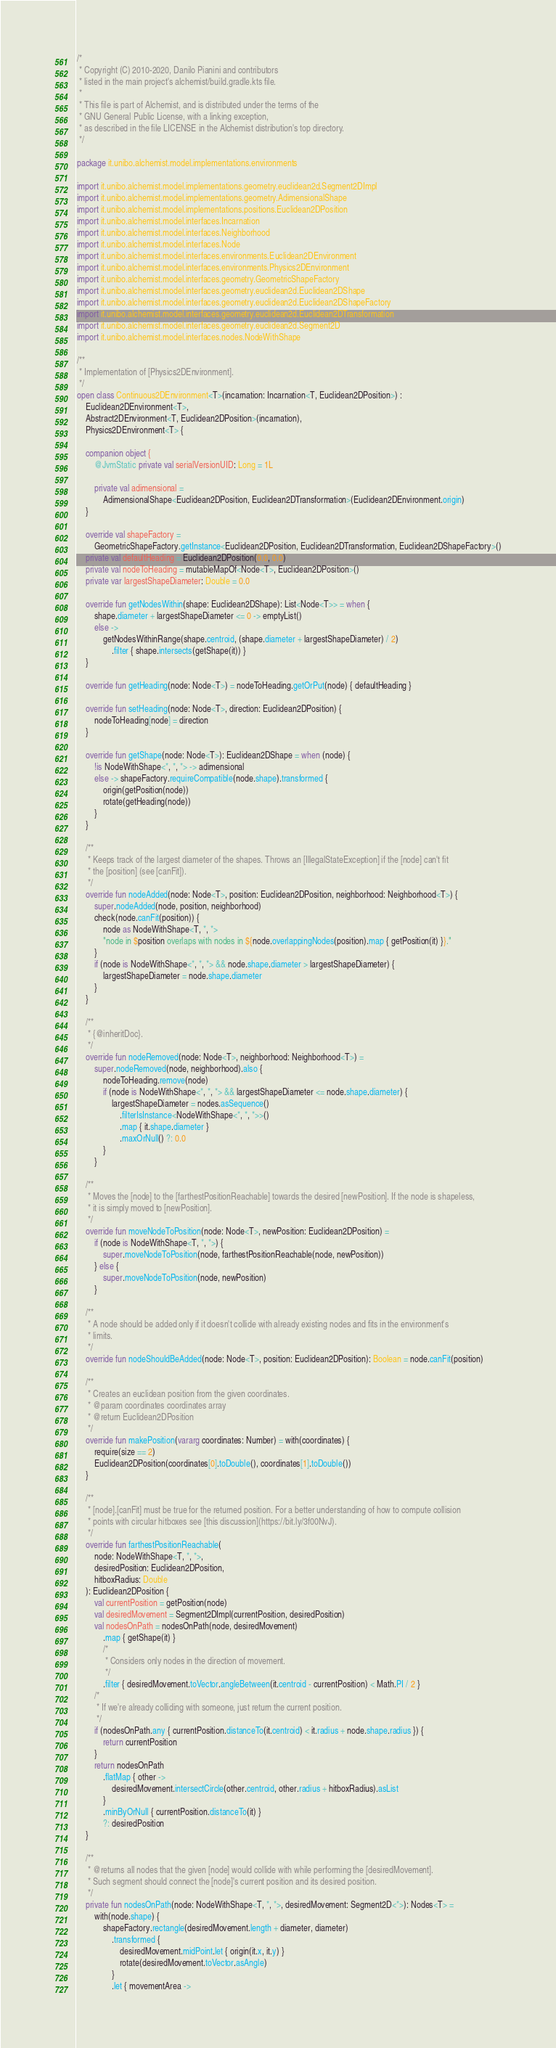Convert code to text. <code><loc_0><loc_0><loc_500><loc_500><_Kotlin_>/*
 * Copyright (C) 2010-2020, Danilo Pianini and contributors
 * listed in the main project's alchemist/build.gradle.kts file.
 *
 * This file is part of Alchemist, and is distributed under the terms of the
 * GNU General Public License, with a linking exception,
 * as described in the file LICENSE in the Alchemist distribution's top directory.
 */

package it.unibo.alchemist.model.implementations.environments

import it.unibo.alchemist.model.implementations.geometry.euclidean2d.Segment2DImpl
import it.unibo.alchemist.model.implementations.geometry.AdimensionalShape
import it.unibo.alchemist.model.implementations.positions.Euclidean2DPosition
import it.unibo.alchemist.model.interfaces.Incarnation
import it.unibo.alchemist.model.interfaces.Neighborhood
import it.unibo.alchemist.model.interfaces.Node
import it.unibo.alchemist.model.interfaces.environments.Euclidean2DEnvironment
import it.unibo.alchemist.model.interfaces.environments.Physics2DEnvironment
import it.unibo.alchemist.model.interfaces.geometry.GeometricShapeFactory
import it.unibo.alchemist.model.interfaces.geometry.euclidean2d.Euclidean2DShape
import it.unibo.alchemist.model.interfaces.geometry.euclidean2d.Euclidean2DShapeFactory
import it.unibo.alchemist.model.interfaces.geometry.euclidean2d.Euclidean2DTransformation
import it.unibo.alchemist.model.interfaces.geometry.euclidean2d.Segment2D
import it.unibo.alchemist.model.interfaces.nodes.NodeWithShape

/**
 * Implementation of [Physics2DEnvironment].
 */
open class Continuous2DEnvironment<T>(incarnation: Incarnation<T, Euclidean2DPosition>) :
    Euclidean2DEnvironment<T>,
    Abstract2DEnvironment<T, Euclidean2DPosition>(incarnation),
    Physics2DEnvironment<T> {

    companion object {
        @JvmStatic private val serialVersionUID: Long = 1L

        private val adimensional =
            AdimensionalShape<Euclidean2DPosition, Euclidean2DTransformation>(Euclidean2DEnvironment.origin)
    }

    override val shapeFactory =
        GeometricShapeFactory.getInstance<Euclidean2DPosition, Euclidean2DTransformation, Euclidean2DShapeFactory>()
    private val defaultHeading = Euclidean2DPosition(0.0, 0.0)
    private val nodeToHeading = mutableMapOf<Node<T>, Euclidean2DPosition>()
    private var largestShapeDiameter: Double = 0.0

    override fun getNodesWithin(shape: Euclidean2DShape): List<Node<T>> = when {
        shape.diameter + largestShapeDiameter <= 0 -> emptyList()
        else ->
            getNodesWithinRange(shape.centroid, (shape.diameter + largestShapeDiameter) / 2)
                .filter { shape.intersects(getShape(it)) }
    }

    override fun getHeading(node: Node<T>) = nodeToHeading.getOrPut(node) { defaultHeading }

    override fun setHeading(node: Node<T>, direction: Euclidean2DPosition) {
        nodeToHeading[node] = direction
    }

    override fun getShape(node: Node<T>): Euclidean2DShape = when (node) {
        !is NodeWithShape<*, *, *> -> adimensional
        else -> shapeFactory.requireCompatible(node.shape).transformed {
            origin(getPosition(node))
            rotate(getHeading(node))
        }
    }

    /**
     * Keeps track of the largest diameter of the shapes. Throws an [IllegalStateException] if the [node] can't fit
     * the [position] (see [canFit]).
     */
    override fun nodeAdded(node: Node<T>, position: Euclidean2DPosition, neighborhood: Neighborhood<T>) {
        super.nodeAdded(node, position, neighborhood)
        check(node.canFit(position)) {
            node as NodeWithShape<T, *, *>
            "node in $position overlaps with nodes in ${node.overlappingNodes(position).map { getPosition(it) }}."
        }
        if (node is NodeWithShape<*, *, *> && node.shape.diameter > largestShapeDiameter) {
            largestShapeDiameter = node.shape.diameter
        }
    }

    /**
     * {@inheritDoc}.
     */
    override fun nodeRemoved(node: Node<T>, neighborhood: Neighborhood<T>) =
        super.nodeRemoved(node, neighborhood).also {
            nodeToHeading.remove(node)
            if (node is NodeWithShape<*, *, *> && largestShapeDiameter <= node.shape.diameter) {
                largestShapeDiameter = nodes.asSequence()
                    .filterIsInstance<NodeWithShape<*, *, *>>()
                    .map { it.shape.diameter }
                    .maxOrNull() ?: 0.0
            }
        }

    /**
     * Moves the [node] to the [farthestPositionReachable] towards the desired [newPosition]. If the node is shapeless,
     * it is simply moved to [newPosition].
     */
    override fun moveNodeToPosition(node: Node<T>, newPosition: Euclidean2DPosition) =
        if (node is NodeWithShape<T, *, *>) {
            super.moveNodeToPosition(node, farthestPositionReachable(node, newPosition))
        } else {
            super.moveNodeToPosition(node, newPosition)
        }

    /**
     * A node should be added only if it doesn't collide with already existing nodes and fits in the environment's
     * limits.
     */
    override fun nodeShouldBeAdded(node: Node<T>, position: Euclidean2DPosition): Boolean = node.canFit(position)

    /**
     * Creates an euclidean position from the given coordinates.
     * @param coordinates coordinates array
     * @return Euclidean2DPosition
     */
    override fun makePosition(vararg coordinates: Number) = with(coordinates) {
        require(size == 2)
        Euclidean2DPosition(coordinates[0].toDouble(), coordinates[1].toDouble())
    }

    /**
     * [node].[canFit] must be true for the returned position. For a better understanding of how to compute collision
     * points with circular hitboxes see [this discussion](https://bit.ly/3f00NvJ).
     */
    override fun farthestPositionReachable(
        node: NodeWithShape<T, *, *>,
        desiredPosition: Euclidean2DPosition,
        hitboxRadius: Double
    ): Euclidean2DPosition {
        val currentPosition = getPosition(node)
        val desiredMovement = Segment2DImpl(currentPosition, desiredPosition)
        val nodesOnPath = nodesOnPath(node, desiredMovement)
            .map { getShape(it) }
            /*
             * Considers only nodes in the direction of movement.
             */
            .filter { desiredMovement.toVector.angleBetween(it.centroid - currentPosition) < Math.PI / 2 }
        /*
         * If we're already colliding with someone, just return the current position.
         */
        if (nodesOnPath.any { currentPosition.distanceTo(it.centroid) < it.radius + node.shape.radius }) {
            return currentPosition
        }
        return nodesOnPath
            .flatMap { other ->
                desiredMovement.intersectCircle(other.centroid, other.radius + hitboxRadius).asList
            }
            .minByOrNull { currentPosition.distanceTo(it) }
            ?: desiredPosition
    }

    /**
     * @returns all nodes that the given [node] would collide with while performing the [desiredMovement].
     * Such segment should connect the [node]'s current position and its desired position.
     */
    private fun nodesOnPath(node: NodeWithShape<T, *, *>, desiredMovement: Segment2D<*>): Nodes<T> =
        with(node.shape) {
            shapeFactory.rectangle(desiredMovement.length + diameter, diameter)
                .transformed {
                    desiredMovement.midPoint.let { origin(it.x, it.y) }
                    rotate(desiredMovement.toVector.asAngle)
                }
                .let { movementArea -></code> 